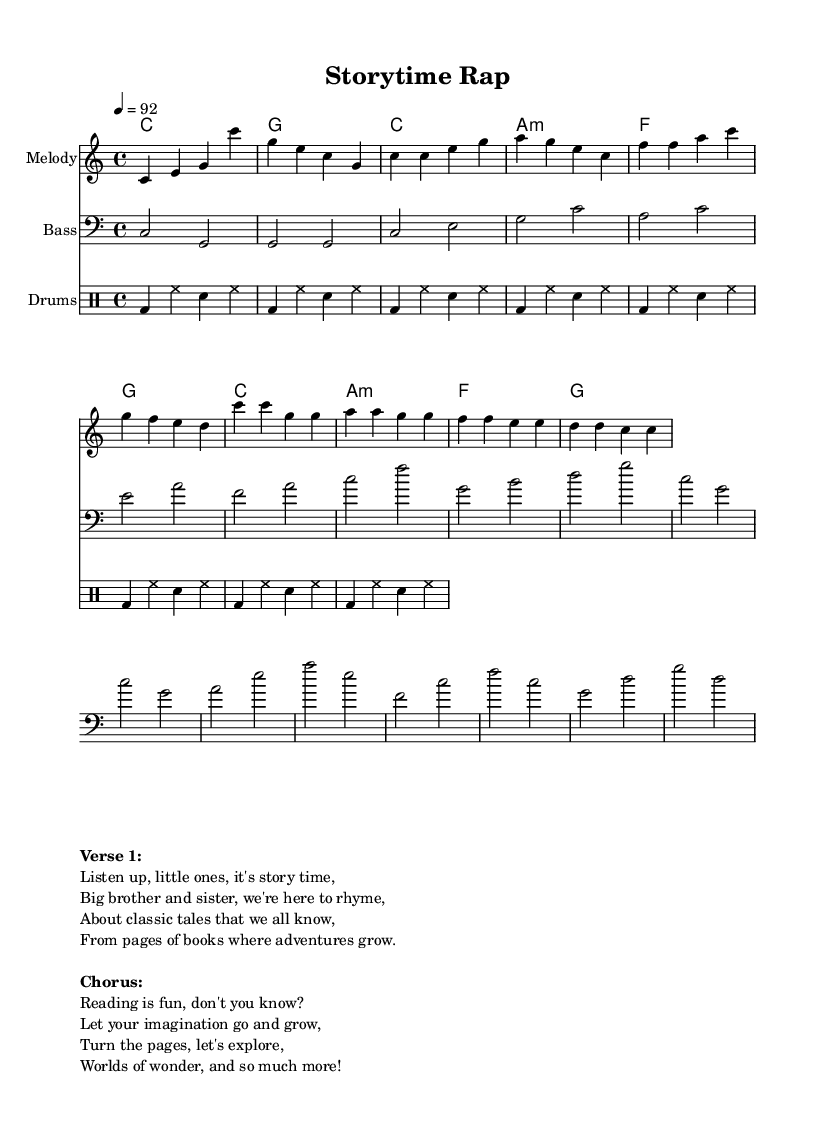What is the key signature of this music? The key signature is indicated at the beginning of the score, showing that the piece is in C major. C major has no sharps or flats.
Answer: C major What is the time signature of this music? The time signature is shown at the start of the score as 4/4, which means there are four beats in each measure.
Answer: 4/4 What is the tempo marking for this piece? The tempo marking is indicated in the global section of the score, stating that the piece should be played at a speed of 92 beats per minute.
Answer: 92 How many measures are in the chorus section? The chorus is comprised of four lines, and each line represents one measure, making a total of four measures in the chorus section.
Answer: 4 What is the primary theme of the rap lyrics? The lyrics convey a message about the joy of reading and exploring stories, as well as encouraging imagination and adventure through books.
Answer: Imagination and adventure What type of rhythm pattern is used in the drum section? The drum patterns are laid out in a repeated sequence, featuring kick drum, hi-hat, and snare; specifically highlighted as four beats for the kick followed by the hi-hat alternating with the snare.
Answer: Alternating kick and hi-hat Who is narrating in this rap song? The narrator is indicated as “big brother and sister,” suggesting that siblings are sharing the storytelling and is inclusive of the younger audience.
Answer: Siblings 